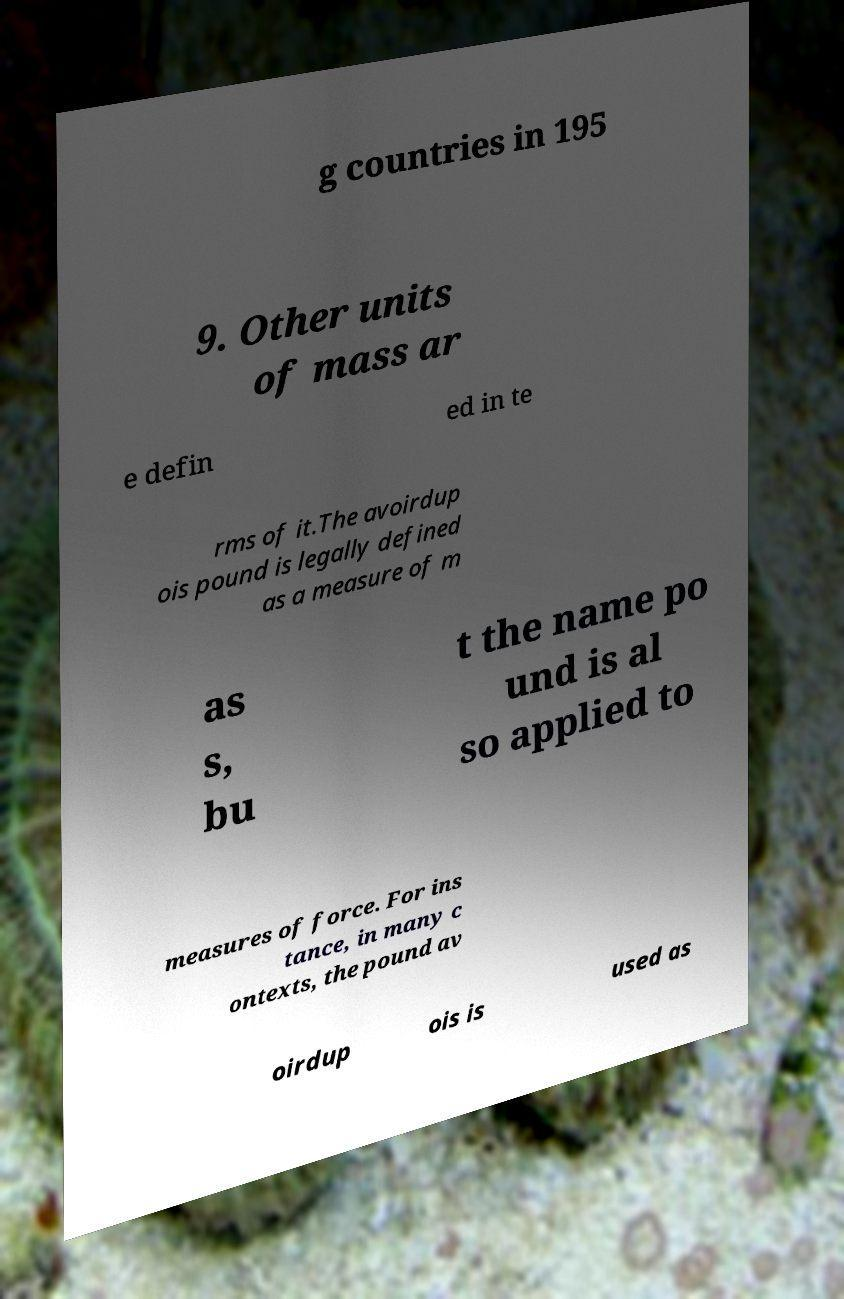What messages or text are displayed in this image? I need them in a readable, typed format. g countries in 195 9. Other units of mass ar e defin ed in te rms of it.The avoirdup ois pound is legally defined as a measure of m as s, bu t the name po und is al so applied to measures of force. For ins tance, in many c ontexts, the pound av oirdup ois is used as 